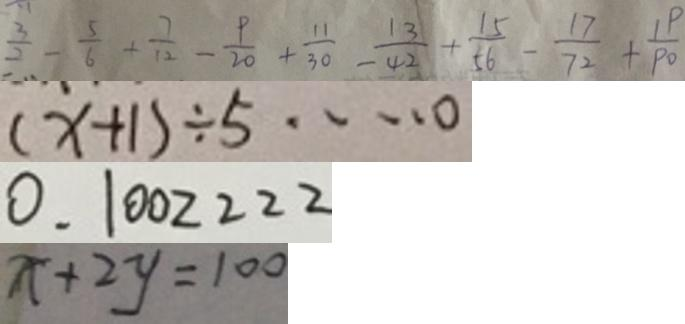<formula> <loc_0><loc_0><loc_500><loc_500>\frac { 3 } { 2 } - \frac { 5 } { 6 } + \frac { 7 } { 1 2 } - \frac { 9 } { 2 0 } + \frac { 1 1 } { 3 0 } - \frac { 1 3 } { 4 2 } + \frac { 1 5 } { 5 6 } - \frac { 1 7 } { 7 2 } + \frac { 1 9 } { 9 0 } 
 ( x + 1 ) \div 5 \cdots 0 
 0 . 1 0 0 2 2 2 2 
 x + 2 y = 1 0 0</formula> 